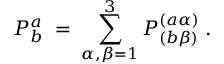<formula> <loc_0><loc_0><loc_500><loc_500>P _ { b } ^ { a } \, = \, \sum _ { \alpha , \beta = 1 } ^ { 3 } P _ { ( b \beta ) } ^ { ( a \alpha ) } \, .</formula> 